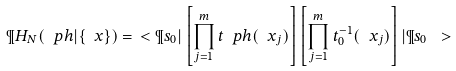<formula> <loc_0><loc_0><loc_500><loc_500>\P H _ { N } ( \ p h | \{ \ x \} ) = \ < \P s _ { 0 } | \left [ \prod _ { j = 1 } ^ { m } t _ { \ } p h ( \ x _ { j } ) \right ] \left [ \prod _ { j = 1 } ^ { m } t _ { 0 } ^ { - 1 } ( \ x _ { j } ) \right ] | \P s _ { 0 } \ ></formula> 